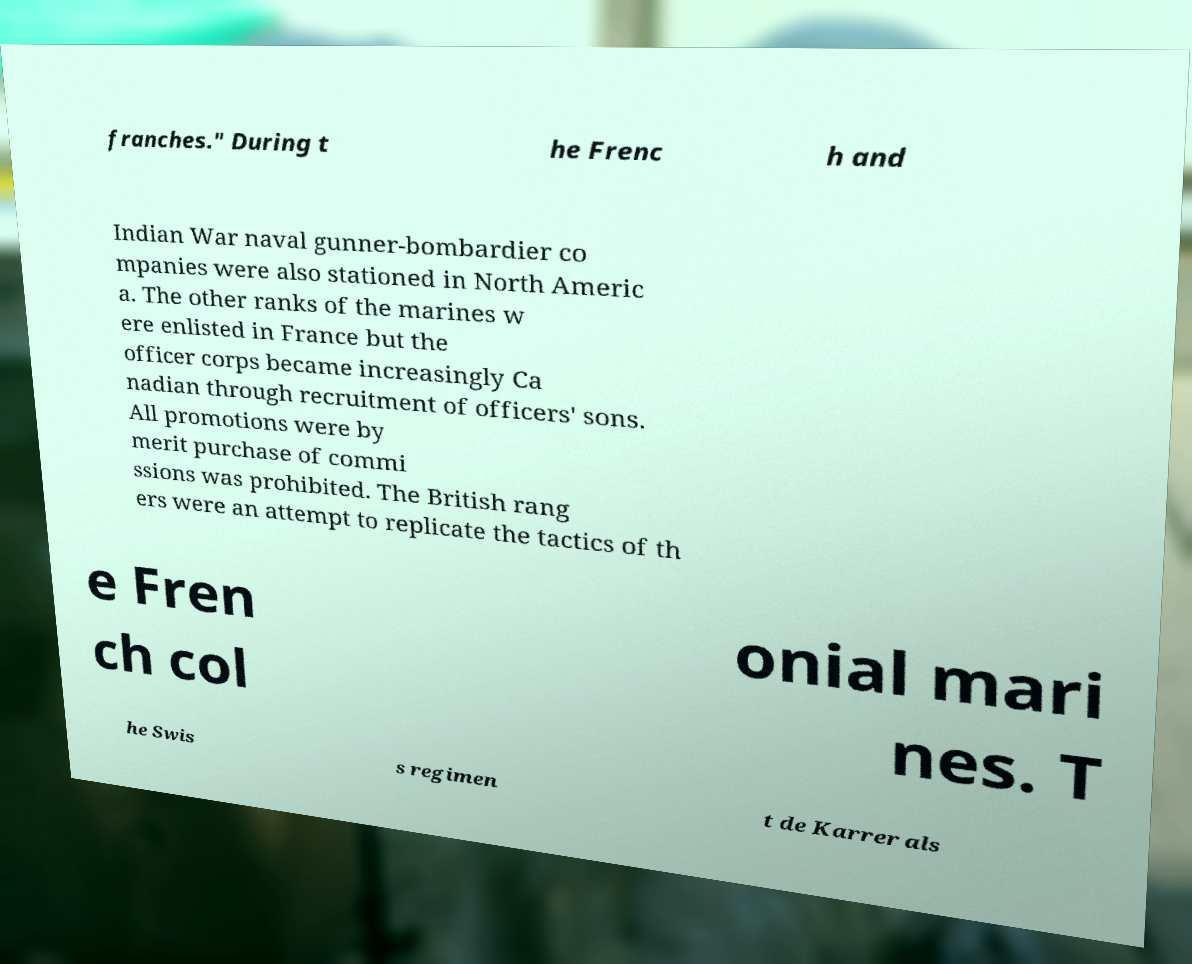Please read and relay the text visible in this image. What does it say? franches." During t he Frenc h and Indian War naval gunner-bombardier co mpanies were also stationed in North Americ a. The other ranks of the marines w ere enlisted in France but the officer corps became increasingly Ca nadian through recruitment of officers' sons. All promotions were by merit purchase of commi ssions was prohibited. The British rang ers were an attempt to replicate the tactics of th e Fren ch col onial mari nes. T he Swis s regimen t de Karrer als 